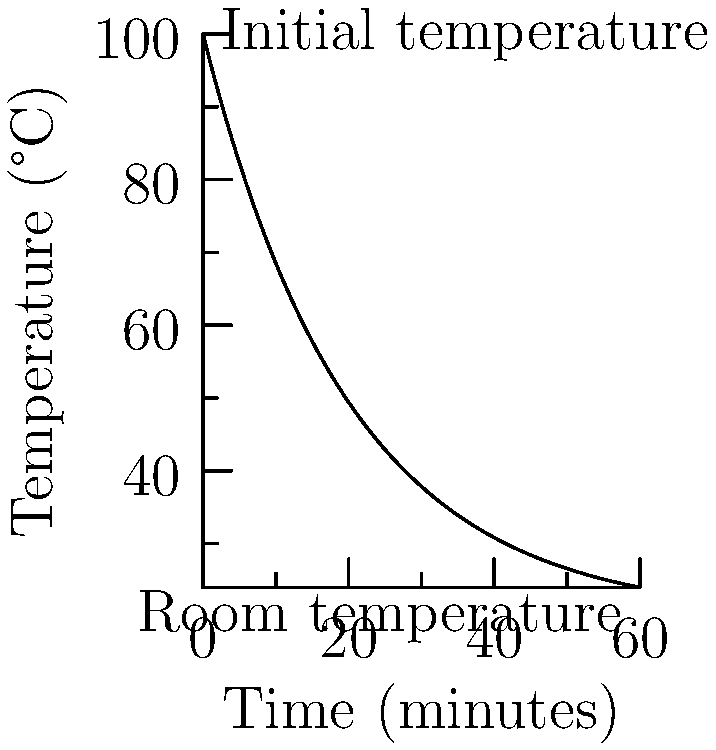In a dimly lit study, a cup of freshly brewed Earl Grey tea is left to cool. The tea's temperature ($T$) in degrees Celsius as a function of time ($t$) in minutes is given by the equation:

$$ T(t) = 80e^{-0.05t} + 20 $$

Where 20°C is the ambient room temperature. How long will it take for the tea to cool to 50°C, leaving it barely warm enough to provide comfort on a dreary London evening? To find the time when the tea reaches 50°C, we need to solve the equation:

1) Set up the equation:
   $$ 50 = 80e^{-0.05t} + 20 $$

2) Subtract 20 from both sides:
   $$ 30 = 80e^{-0.05t} $$

3) Divide both sides by 80:
   $$ \frac{3}{8} = e^{-0.05t} $$

4) Take the natural logarithm of both sides:
   $$ \ln(\frac{3}{8}) = -0.05t $$

5) Solve for t:
   $$ t = -\frac{\ln(\frac{3}{8})}{0.05} $$

6) Calculate the result:
   $$ t \approx 18.47 \text{ minutes} $$

This result reflects the gradual decay of warmth, much like the fading of hope in a melancholic tale.
Answer: 18.47 minutes 